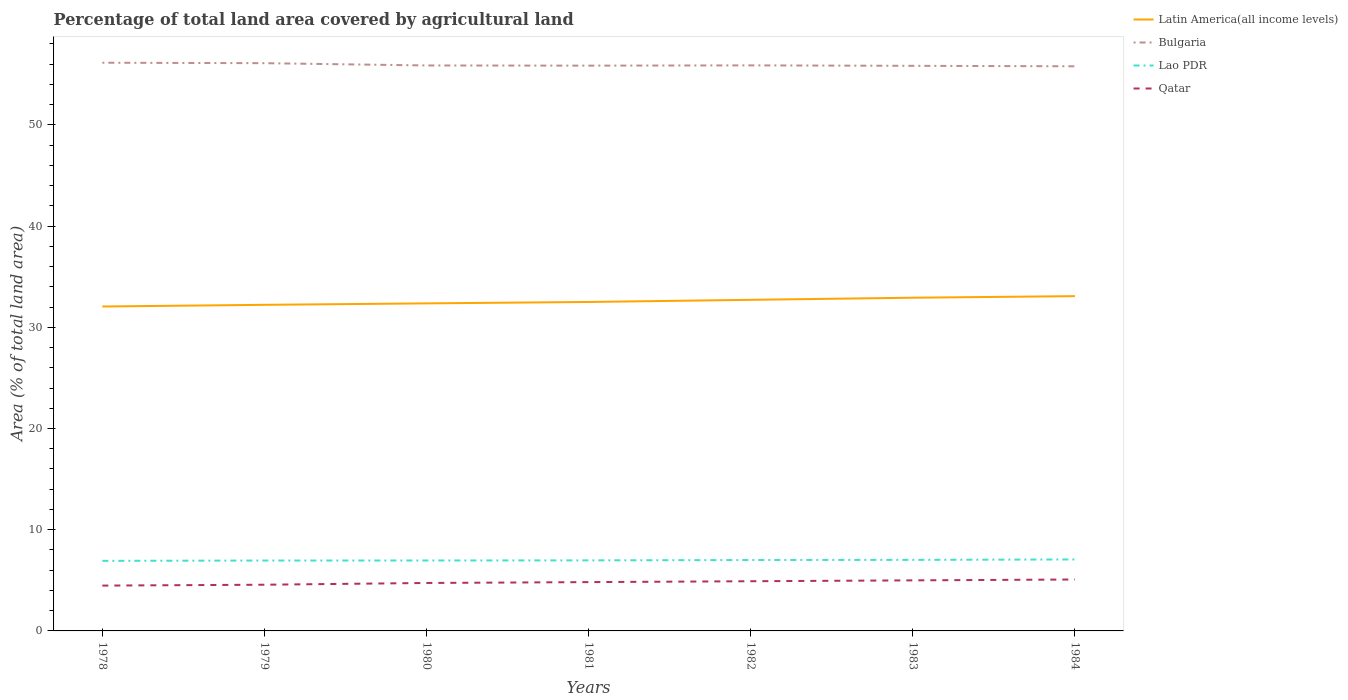Across all years, what is the maximum percentage of agricultural land in Bulgaria?
Provide a succinct answer. 55.79. What is the total percentage of agricultural land in Bulgaria in the graph?
Your response must be concise. 0.05. What is the difference between the highest and the second highest percentage of agricultural land in Lao PDR?
Give a very brief answer. 0.14. What is the difference between the highest and the lowest percentage of agricultural land in Qatar?
Provide a succinct answer. 4. Is the percentage of agricultural land in Qatar strictly greater than the percentage of agricultural land in Lao PDR over the years?
Your response must be concise. Yes. How many lines are there?
Ensure brevity in your answer.  4. What is the difference between two consecutive major ticks on the Y-axis?
Offer a terse response. 10. Are the values on the major ticks of Y-axis written in scientific E-notation?
Ensure brevity in your answer.  No. Does the graph contain any zero values?
Keep it short and to the point. No. Does the graph contain grids?
Give a very brief answer. No. How many legend labels are there?
Make the answer very short. 4. What is the title of the graph?
Provide a succinct answer. Percentage of total land area covered by agricultural land. What is the label or title of the Y-axis?
Offer a terse response. Area (% of total land area). What is the Area (% of total land area) of Latin America(all income levels) in 1978?
Provide a succinct answer. 32.05. What is the Area (% of total land area) in Bulgaria in 1978?
Ensure brevity in your answer.  56.14. What is the Area (% of total land area) of Lao PDR in 1978?
Your answer should be very brief. 6.92. What is the Area (% of total land area) of Qatar in 1978?
Ensure brevity in your answer.  4.48. What is the Area (% of total land area) of Latin America(all income levels) in 1979?
Your answer should be very brief. 32.22. What is the Area (% of total land area) in Bulgaria in 1979?
Your response must be concise. 56.1. What is the Area (% of total land area) of Lao PDR in 1979?
Offer a terse response. 6.95. What is the Area (% of total land area) of Qatar in 1979?
Provide a succinct answer. 4.57. What is the Area (% of total land area) in Latin America(all income levels) in 1980?
Your response must be concise. 32.36. What is the Area (% of total land area) of Bulgaria in 1980?
Offer a very short reply. 55.87. What is the Area (% of total land area) in Lao PDR in 1980?
Offer a very short reply. 6.96. What is the Area (% of total land area) of Qatar in 1980?
Offer a terse response. 4.74. What is the Area (% of total land area) of Latin America(all income levels) in 1981?
Provide a short and direct response. 32.5. What is the Area (% of total land area) of Bulgaria in 1981?
Give a very brief answer. 55.85. What is the Area (% of total land area) in Lao PDR in 1981?
Your answer should be very brief. 6.97. What is the Area (% of total land area) of Qatar in 1981?
Offer a terse response. 4.82. What is the Area (% of total land area) in Latin America(all income levels) in 1982?
Your answer should be compact. 32.71. What is the Area (% of total land area) of Bulgaria in 1982?
Your answer should be compact. 55.88. What is the Area (% of total land area) in Lao PDR in 1982?
Your answer should be compact. 7.01. What is the Area (% of total land area) in Qatar in 1982?
Ensure brevity in your answer.  4.91. What is the Area (% of total land area) in Latin America(all income levels) in 1983?
Offer a very short reply. 32.92. What is the Area (% of total land area) of Bulgaria in 1983?
Your answer should be compact. 55.83. What is the Area (% of total land area) of Lao PDR in 1983?
Your response must be concise. 7.02. What is the Area (% of total land area) in Qatar in 1983?
Keep it short and to the point. 5. What is the Area (% of total land area) of Latin America(all income levels) in 1984?
Offer a very short reply. 33.08. What is the Area (% of total land area) of Bulgaria in 1984?
Provide a succinct answer. 55.79. What is the Area (% of total land area) in Lao PDR in 1984?
Keep it short and to the point. 7.06. What is the Area (% of total land area) in Qatar in 1984?
Keep it short and to the point. 5.08. Across all years, what is the maximum Area (% of total land area) of Latin America(all income levels)?
Ensure brevity in your answer.  33.08. Across all years, what is the maximum Area (% of total land area) in Bulgaria?
Make the answer very short. 56.14. Across all years, what is the maximum Area (% of total land area) in Lao PDR?
Make the answer very short. 7.06. Across all years, what is the maximum Area (% of total land area) in Qatar?
Your answer should be compact. 5.08. Across all years, what is the minimum Area (% of total land area) of Latin America(all income levels)?
Keep it short and to the point. 32.05. Across all years, what is the minimum Area (% of total land area) in Bulgaria?
Your answer should be compact. 55.79. Across all years, what is the minimum Area (% of total land area) of Lao PDR?
Your answer should be very brief. 6.92. Across all years, what is the minimum Area (% of total land area) of Qatar?
Offer a very short reply. 4.48. What is the total Area (% of total land area) in Latin America(all income levels) in the graph?
Give a very brief answer. 227.86. What is the total Area (% of total land area) of Bulgaria in the graph?
Keep it short and to the point. 391.47. What is the total Area (% of total land area) of Lao PDR in the graph?
Make the answer very short. 48.9. What is the total Area (% of total land area) of Qatar in the graph?
Make the answer very short. 33.59. What is the difference between the Area (% of total land area) of Latin America(all income levels) in 1978 and that in 1979?
Offer a very short reply. -0.17. What is the difference between the Area (% of total land area) in Bulgaria in 1978 and that in 1979?
Ensure brevity in your answer.  0.05. What is the difference between the Area (% of total land area) of Lao PDR in 1978 and that in 1979?
Offer a very short reply. -0.03. What is the difference between the Area (% of total land area) in Qatar in 1978 and that in 1979?
Provide a succinct answer. -0.09. What is the difference between the Area (% of total land area) of Latin America(all income levels) in 1978 and that in 1980?
Ensure brevity in your answer.  -0.31. What is the difference between the Area (% of total land area) of Bulgaria in 1978 and that in 1980?
Keep it short and to the point. 0.27. What is the difference between the Area (% of total land area) in Lao PDR in 1978 and that in 1980?
Ensure brevity in your answer.  -0.03. What is the difference between the Area (% of total land area) of Qatar in 1978 and that in 1980?
Your answer should be compact. -0.26. What is the difference between the Area (% of total land area) of Latin America(all income levels) in 1978 and that in 1981?
Your answer should be very brief. -0.45. What is the difference between the Area (% of total land area) of Bulgaria in 1978 and that in 1981?
Provide a short and direct response. 0.29. What is the difference between the Area (% of total land area) of Lao PDR in 1978 and that in 1981?
Ensure brevity in your answer.  -0.05. What is the difference between the Area (% of total land area) of Qatar in 1978 and that in 1981?
Provide a short and direct response. -0.34. What is the difference between the Area (% of total land area) in Latin America(all income levels) in 1978 and that in 1982?
Keep it short and to the point. -0.66. What is the difference between the Area (% of total land area) of Bulgaria in 1978 and that in 1982?
Offer a terse response. 0.26. What is the difference between the Area (% of total land area) of Lao PDR in 1978 and that in 1982?
Give a very brief answer. -0.08. What is the difference between the Area (% of total land area) in Qatar in 1978 and that in 1982?
Your response must be concise. -0.43. What is the difference between the Area (% of total land area) in Latin America(all income levels) in 1978 and that in 1983?
Provide a short and direct response. -0.87. What is the difference between the Area (% of total land area) in Bulgaria in 1978 and that in 1983?
Keep it short and to the point. 0.31. What is the difference between the Area (% of total land area) in Lao PDR in 1978 and that in 1983?
Give a very brief answer. -0.1. What is the difference between the Area (% of total land area) of Qatar in 1978 and that in 1983?
Give a very brief answer. -0.52. What is the difference between the Area (% of total land area) in Latin America(all income levels) in 1978 and that in 1984?
Give a very brief answer. -1.02. What is the difference between the Area (% of total land area) in Bulgaria in 1978 and that in 1984?
Offer a terse response. 0.35. What is the difference between the Area (% of total land area) in Lao PDR in 1978 and that in 1984?
Offer a very short reply. -0.14. What is the difference between the Area (% of total land area) in Qatar in 1978 and that in 1984?
Ensure brevity in your answer.  -0.6. What is the difference between the Area (% of total land area) of Latin America(all income levels) in 1979 and that in 1980?
Your response must be concise. -0.14. What is the difference between the Area (% of total land area) in Bulgaria in 1979 and that in 1980?
Keep it short and to the point. 0.23. What is the difference between the Area (% of total land area) in Lao PDR in 1979 and that in 1980?
Offer a very short reply. -0. What is the difference between the Area (% of total land area) in Qatar in 1979 and that in 1980?
Your response must be concise. -0.17. What is the difference between the Area (% of total land area) in Latin America(all income levels) in 1979 and that in 1981?
Your answer should be very brief. -0.28. What is the difference between the Area (% of total land area) in Bulgaria in 1979 and that in 1981?
Give a very brief answer. 0.24. What is the difference between the Area (% of total land area) in Lao PDR in 1979 and that in 1981?
Make the answer very short. -0.02. What is the difference between the Area (% of total land area) of Qatar in 1979 and that in 1981?
Your response must be concise. -0.26. What is the difference between the Area (% of total land area) in Latin America(all income levels) in 1979 and that in 1982?
Ensure brevity in your answer.  -0.49. What is the difference between the Area (% of total land area) in Bulgaria in 1979 and that in 1982?
Ensure brevity in your answer.  0.22. What is the difference between the Area (% of total land area) of Lao PDR in 1979 and that in 1982?
Make the answer very short. -0.05. What is the difference between the Area (% of total land area) in Qatar in 1979 and that in 1982?
Keep it short and to the point. -0.34. What is the difference between the Area (% of total land area) in Latin America(all income levels) in 1979 and that in 1983?
Give a very brief answer. -0.7. What is the difference between the Area (% of total land area) of Bulgaria in 1979 and that in 1983?
Provide a succinct answer. 0.26. What is the difference between the Area (% of total land area) of Lao PDR in 1979 and that in 1983?
Give a very brief answer. -0.07. What is the difference between the Area (% of total land area) of Qatar in 1979 and that in 1983?
Provide a short and direct response. -0.43. What is the difference between the Area (% of total land area) in Latin America(all income levels) in 1979 and that in 1984?
Provide a succinct answer. -0.86. What is the difference between the Area (% of total land area) in Bulgaria in 1979 and that in 1984?
Make the answer very short. 0.31. What is the difference between the Area (% of total land area) in Lao PDR in 1979 and that in 1984?
Offer a terse response. -0.11. What is the difference between the Area (% of total land area) in Qatar in 1979 and that in 1984?
Make the answer very short. -0.52. What is the difference between the Area (% of total land area) in Latin America(all income levels) in 1980 and that in 1981?
Give a very brief answer. -0.14. What is the difference between the Area (% of total land area) in Bulgaria in 1980 and that in 1981?
Provide a succinct answer. 0.02. What is the difference between the Area (% of total land area) in Lao PDR in 1980 and that in 1981?
Provide a short and direct response. -0.01. What is the difference between the Area (% of total land area) in Qatar in 1980 and that in 1981?
Make the answer very short. -0.09. What is the difference between the Area (% of total land area) in Latin America(all income levels) in 1980 and that in 1982?
Ensure brevity in your answer.  -0.35. What is the difference between the Area (% of total land area) in Bulgaria in 1980 and that in 1982?
Keep it short and to the point. -0.01. What is the difference between the Area (% of total land area) in Lao PDR in 1980 and that in 1982?
Give a very brief answer. -0.05. What is the difference between the Area (% of total land area) in Qatar in 1980 and that in 1982?
Give a very brief answer. -0.17. What is the difference between the Area (% of total land area) of Latin America(all income levels) in 1980 and that in 1983?
Provide a short and direct response. -0.56. What is the difference between the Area (% of total land area) in Bulgaria in 1980 and that in 1983?
Give a very brief answer. 0.04. What is the difference between the Area (% of total land area) in Lao PDR in 1980 and that in 1983?
Make the answer very short. -0.06. What is the difference between the Area (% of total land area) of Qatar in 1980 and that in 1983?
Offer a terse response. -0.26. What is the difference between the Area (% of total land area) of Latin America(all income levels) in 1980 and that in 1984?
Keep it short and to the point. -0.71. What is the difference between the Area (% of total land area) in Bulgaria in 1980 and that in 1984?
Keep it short and to the point. 0.08. What is the difference between the Area (% of total land area) in Lao PDR in 1980 and that in 1984?
Offer a terse response. -0.1. What is the difference between the Area (% of total land area) in Qatar in 1980 and that in 1984?
Offer a terse response. -0.34. What is the difference between the Area (% of total land area) of Latin America(all income levels) in 1981 and that in 1982?
Ensure brevity in your answer.  -0.21. What is the difference between the Area (% of total land area) in Bulgaria in 1981 and that in 1982?
Your response must be concise. -0.03. What is the difference between the Area (% of total land area) in Lao PDR in 1981 and that in 1982?
Offer a terse response. -0.03. What is the difference between the Area (% of total land area) in Qatar in 1981 and that in 1982?
Offer a terse response. -0.09. What is the difference between the Area (% of total land area) in Latin America(all income levels) in 1981 and that in 1983?
Give a very brief answer. -0.42. What is the difference between the Area (% of total land area) of Bulgaria in 1981 and that in 1983?
Offer a very short reply. 0.02. What is the difference between the Area (% of total land area) of Lao PDR in 1981 and that in 1983?
Give a very brief answer. -0.05. What is the difference between the Area (% of total land area) in Qatar in 1981 and that in 1983?
Your response must be concise. -0.17. What is the difference between the Area (% of total land area) in Latin America(all income levels) in 1981 and that in 1984?
Keep it short and to the point. -0.58. What is the difference between the Area (% of total land area) of Bulgaria in 1981 and that in 1984?
Provide a succinct answer. 0.06. What is the difference between the Area (% of total land area) of Lao PDR in 1981 and that in 1984?
Your response must be concise. -0.09. What is the difference between the Area (% of total land area) of Qatar in 1981 and that in 1984?
Ensure brevity in your answer.  -0.26. What is the difference between the Area (% of total land area) of Latin America(all income levels) in 1982 and that in 1983?
Your response must be concise. -0.21. What is the difference between the Area (% of total land area) in Bulgaria in 1982 and that in 1983?
Provide a short and direct response. 0.05. What is the difference between the Area (% of total land area) of Lao PDR in 1982 and that in 1983?
Offer a very short reply. -0.01. What is the difference between the Area (% of total land area) of Qatar in 1982 and that in 1983?
Provide a short and direct response. -0.09. What is the difference between the Area (% of total land area) of Latin America(all income levels) in 1982 and that in 1984?
Provide a short and direct response. -0.36. What is the difference between the Area (% of total land area) of Bulgaria in 1982 and that in 1984?
Offer a very short reply. 0.09. What is the difference between the Area (% of total land area) in Lao PDR in 1982 and that in 1984?
Offer a very short reply. -0.06. What is the difference between the Area (% of total land area) of Qatar in 1982 and that in 1984?
Keep it short and to the point. -0.17. What is the difference between the Area (% of total land area) of Latin America(all income levels) in 1983 and that in 1984?
Your response must be concise. -0.16. What is the difference between the Area (% of total land area) of Bulgaria in 1983 and that in 1984?
Provide a short and direct response. 0.05. What is the difference between the Area (% of total land area) of Lao PDR in 1983 and that in 1984?
Make the answer very short. -0.04. What is the difference between the Area (% of total land area) of Qatar in 1983 and that in 1984?
Your response must be concise. -0.09. What is the difference between the Area (% of total land area) in Latin America(all income levels) in 1978 and the Area (% of total land area) in Bulgaria in 1979?
Your response must be concise. -24.04. What is the difference between the Area (% of total land area) of Latin America(all income levels) in 1978 and the Area (% of total land area) of Lao PDR in 1979?
Offer a terse response. 25.1. What is the difference between the Area (% of total land area) of Latin America(all income levels) in 1978 and the Area (% of total land area) of Qatar in 1979?
Your response must be concise. 27.49. What is the difference between the Area (% of total land area) in Bulgaria in 1978 and the Area (% of total land area) in Lao PDR in 1979?
Ensure brevity in your answer.  49.19. What is the difference between the Area (% of total land area) in Bulgaria in 1978 and the Area (% of total land area) in Qatar in 1979?
Provide a succinct answer. 51.58. What is the difference between the Area (% of total land area) of Lao PDR in 1978 and the Area (% of total land area) of Qatar in 1979?
Offer a very short reply. 2.36. What is the difference between the Area (% of total land area) of Latin America(all income levels) in 1978 and the Area (% of total land area) of Bulgaria in 1980?
Provide a succinct answer. -23.82. What is the difference between the Area (% of total land area) in Latin America(all income levels) in 1978 and the Area (% of total land area) in Lao PDR in 1980?
Offer a terse response. 25.1. What is the difference between the Area (% of total land area) of Latin America(all income levels) in 1978 and the Area (% of total land area) of Qatar in 1980?
Ensure brevity in your answer.  27.32. What is the difference between the Area (% of total land area) in Bulgaria in 1978 and the Area (% of total land area) in Lao PDR in 1980?
Offer a terse response. 49.18. What is the difference between the Area (% of total land area) in Bulgaria in 1978 and the Area (% of total land area) in Qatar in 1980?
Your response must be concise. 51.4. What is the difference between the Area (% of total land area) of Lao PDR in 1978 and the Area (% of total land area) of Qatar in 1980?
Make the answer very short. 2.19. What is the difference between the Area (% of total land area) of Latin America(all income levels) in 1978 and the Area (% of total land area) of Bulgaria in 1981?
Ensure brevity in your answer.  -23.8. What is the difference between the Area (% of total land area) of Latin America(all income levels) in 1978 and the Area (% of total land area) of Lao PDR in 1981?
Your response must be concise. 25.08. What is the difference between the Area (% of total land area) of Latin America(all income levels) in 1978 and the Area (% of total land area) of Qatar in 1981?
Provide a succinct answer. 27.23. What is the difference between the Area (% of total land area) in Bulgaria in 1978 and the Area (% of total land area) in Lao PDR in 1981?
Keep it short and to the point. 49.17. What is the difference between the Area (% of total land area) of Bulgaria in 1978 and the Area (% of total land area) of Qatar in 1981?
Offer a very short reply. 51.32. What is the difference between the Area (% of total land area) of Lao PDR in 1978 and the Area (% of total land area) of Qatar in 1981?
Offer a terse response. 2.1. What is the difference between the Area (% of total land area) in Latin America(all income levels) in 1978 and the Area (% of total land area) in Bulgaria in 1982?
Offer a very short reply. -23.83. What is the difference between the Area (% of total land area) of Latin America(all income levels) in 1978 and the Area (% of total land area) of Lao PDR in 1982?
Offer a terse response. 25.05. What is the difference between the Area (% of total land area) of Latin America(all income levels) in 1978 and the Area (% of total land area) of Qatar in 1982?
Provide a succinct answer. 27.15. What is the difference between the Area (% of total land area) of Bulgaria in 1978 and the Area (% of total land area) of Lao PDR in 1982?
Offer a very short reply. 49.14. What is the difference between the Area (% of total land area) in Bulgaria in 1978 and the Area (% of total land area) in Qatar in 1982?
Ensure brevity in your answer.  51.23. What is the difference between the Area (% of total land area) in Lao PDR in 1978 and the Area (% of total land area) in Qatar in 1982?
Your response must be concise. 2.01. What is the difference between the Area (% of total land area) in Latin America(all income levels) in 1978 and the Area (% of total land area) in Bulgaria in 1983?
Your answer should be compact. -23.78. What is the difference between the Area (% of total land area) of Latin America(all income levels) in 1978 and the Area (% of total land area) of Lao PDR in 1983?
Give a very brief answer. 25.04. What is the difference between the Area (% of total land area) of Latin America(all income levels) in 1978 and the Area (% of total land area) of Qatar in 1983?
Your response must be concise. 27.06. What is the difference between the Area (% of total land area) in Bulgaria in 1978 and the Area (% of total land area) in Lao PDR in 1983?
Offer a terse response. 49.12. What is the difference between the Area (% of total land area) in Bulgaria in 1978 and the Area (% of total land area) in Qatar in 1983?
Provide a succinct answer. 51.15. What is the difference between the Area (% of total land area) of Lao PDR in 1978 and the Area (% of total land area) of Qatar in 1983?
Provide a succinct answer. 1.93. What is the difference between the Area (% of total land area) in Latin America(all income levels) in 1978 and the Area (% of total land area) in Bulgaria in 1984?
Your answer should be compact. -23.73. What is the difference between the Area (% of total land area) in Latin America(all income levels) in 1978 and the Area (% of total land area) in Lao PDR in 1984?
Offer a terse response. 24.99. What is the difference between the Area (% of total land area) in Latin America(all income levels) in 1978 and the Area (% of total land area) in Qatar in 1984?
Provide a succinct answer. 26.97. What is the difference between the Area (% of total land area) in Bulgaria in 1978 and the Area (% of total land area) in Lao PDR in 1984?
Provide a short and direct response. 49.08. What is the difference between the Area (% of total land area) in Bulgaria in 1978 and the Area (% of total land area) in Qatar in 1984?
Your response must be concise. 51.06. What is the difference between the Area (% of total land area) of Lao PDR in 1978 and the Area (% of total land area) of Qatar in 1984?
Your answer should be compact. 1.84. What is the difference between the Area (% of total land area) in Latin America(all income levels) in 1979 and the Area (% of total land area) in Bulgaria in 1980?
Offer a terse response. -23.65. What is the difference between the Area (% of total land area) in Latin America(all income levels) in 1979 and the Area (% of total land area) in Lao PDR in 1980?
Provide a short and direct response. 25.26. What is the difference between the Area (% of total land area) of Latin America(all income levels) in 1979 and the Area (% of total land area) of Qatar in 1980?
Provide a succinct answer. 27.48. What is the difference between the Area (% of total land area) of Bulgaria in 1979 and the Area (% of total land area) of Lao PDR in 1980?
Your answer should be very brief. 49.14. What is the difference between the Area (% of total land area) of Bulgaria in 1979 and the Area (% of total land area) of Qatar in 1980?
Provide a succinct answer. 51.36. What is the difference between the Area (% of total land area) of Lao PDR in 1979 and the Area (% of total land area) of Qatar in 1980?
Your answer should be compact. 2.22. What is the difference between the Area (% of total land area) in Latin America(all income levels) in 1979 and the Area (% of total land area) in Bulgaria in 1981?
Your answer should be very brief. -23.63. What is the difference between the Area (% of total land area) of Latin America(all income levels) in 1979 and the Area (% of total land area) of Lao PDR in 1981?
Offer a terse response. 25.25. What is the difference between the Area (% of total land area) of Latin America(all income levels) in 1979 and the Area (% of total land area) of Qatar in 1981?
Make the answer very short. 27.4. What is the difference between the Area (% of total land area) of Bulgaria in 1979 and the Area (% of total land area) of Lao PDR in 1981?
Offer a terse response. 49.13. What is the difference between the Area (% of total land area) in Bulgaria in 1979 and the Area (% of total land area) in Qatar in 1981?
Your answer should be very brief. 51.27. What is the difference between the Area (% of total land area) in Lao PDR in 1979 and the Area (% of total land area) in Qatar in 1981?
Provide a short and direct response. 2.13. What is the difference between the Area (% of total land area) of Latin America(all income levels) in 1979 and the Area (% of total land area) of Bulgaria in 1982?
Make the answer very short. -23.66. What is the difference between the Area (% of total land area) of Latin America(all income levels) in 1979 and the Area (% of total land area) of Lao PDR in 1982?
Ensure brevity in your answer.  25.21. What is the difference between the Area (% of total land area) of Latin America(all income levels) in 1979 and the Area (% of total land area) of Qatar in 1982?
Offer a very short reply. 27.31. What is the difference between the Area (% of total land area) of Bulgaria in 1979 and the Area (% of total land area) of Lao PDR in 1982?
Offer a terse response. 49.09. What is the difference between the Area (% of total land area) of Bulgaria in 1979 and the Area (% of total land area) of Qatar in 1982?
Make the answer very short. 51.19. What is the difference between the Area (% of total land area) of Lao PDR in 1979 and the Area (% of total land area) of Qatar in 1982?
Give a very brief answer. 2.04. What is the difference between the Area (% of total land area) of Latin America(all income levels) in 1979 and the Area (% of total land area) of Bulgaria in 1983?
Offer a very short reply. -23.61. What is the difference between the Area (% of total land area) of Latin America(all income levels) in 1979 and the Area (% of total land area) of Lao PDR in 1983?
Provide a short and direct response. 25.2. What is the difference between the Area (% of total land area) of Latin America(all income levels) in 1979 and the Area (% of total land area) of Qatar in 1983?
Your response must be concise. 27.22. What is the difference between the Area (% of total land area) of Bulgaria in 1979 and the Area (% of total land area) of Lao PDR in 1983?
Keep it short and to the point. 49.08. What is the difference between the Area (% of total land area) in Bulgaria in 1979 and the Area (% of total land area) in Qatar in 1983?
Your response must be concise. 51.1. What is the difference between the Area (% of total land area) of Lao PDR in 1979 and the Area (% of total land area) of Qatar in 1983?
Keep it short and to the point. 1.96. What is the difference between the Area (% of total land area) of Latin America(all income levels) in 1979 and the Area (% of total land area) of Bulgaria in 1984?
Give a very brief answer. -23.57. What is the difference between the Area (% of total land area) of Latin America(all income levels) in 1979 and the Area (% of total land area) of Lao PDR in 1984?
Your answer should be compact. 25.16. What is the difference between the Area (% of total land area) in Latin America(all income levels) in 1979 and the Area (% of total land area) in Qatar in 1984?
Ensure brevity in your answer.  27.14. What is the difference between the Area (% of total land area) in Bulgaria in 1979 and the Area (% of total land area) in Lao PDR in 1984?
Give a very brief answer. 49.03. What is the difference between the Area (% of total land area) in Bulgaria in 1979 and the Area (% of total land area) in Qatar in 1984?
Offer a very short reply. 51.02. What is the difference between the Area (% of total land area) of Lao PDR in 1979 and the Area (% of total land area) of Qatar in 1984?
Your response must be concise. 1.87. What is the difference between the Area (% of total land area) in Latin America(all income levels) in 1980 and the Area (% of total land area) in Bulgaria in 1981?
Make the answer very short. -23.49. What is the difference between the Area (% of total land area) of Latin America(all income levels) in 1980 and the Area (% of total land area) of Lao PDR in 1981?
Provide a succinct answer. 25.39. What is the difference between the Area (% of total land area) of Latin America(all income levels) in 1980 and the Area (% of total land area) of Qatar in 1981?
Your answer should be very brief. 27.54. What is the difference between the Area (% of total land area) of Bulgaria in 1980 and the Area (% of total land area) of Lao PDR in 1981?
Your answer should be very brief. 48.9. What is the difference between the Area (% of total land area) in Bulgaria in 1980 and the Area (% of total land area) in Qatar in 1981?
Your answer should be compact. 51.05. What is the difference between the Area (% of total land area) of Lao PDR in 1980 and the Area (% of total land area) of Qatar in 1981?
Ensure brevity in your answer.  2.13. What is the difference between the Area (% of total land area) in Latin America(all income levels) in 1980 and the Area (% of total land area) in Bulgaria in 1982?
Ensure brevity in your answer.  -23.52. What is the difference between the Area (% of total land area) in Latin America(all income levels) in 1980 and the Area (% of total land area) in Lao PDR in 1982?
Keep it short and to the point. 25.36. What is the difference between the Area (% of total land area) in Latin America(all income levels) in 1980 and the Area (% of total land area) in Qatar in 1982?
Provide a succinct answer. 27.45. What is the difference between the Area (% of total land area) in Bulgaria in 1980 and the Area (% of total land area) in Lao PDR in 1982?
Keep it short and to the point. 48.86. What is the difference between the Area (% of total land area) in Bulgaria in 1980 and the Area (% of total land area) in Qatar in 1982?
Your response must be concise. 50.96. What is the difference between the Area (% of total land area) of Lao PDR in 1980 and the Area (% of total land area) of Qatar in 1982?
Your answer should be very brief. 2.05. What is the difference between the Area (% of total land area) in Latin America(all income levels) in 1980 and the Area (% of total land area) in Bulgaria in 1983?
Ensure brevity in your answer.  -23.47. What is the difference between the Area (% of total land area) in Latin America(all income levels) in 1980 and the Area (% of total land area) in Lao PDR in 1983?
Offer a very short reply. 25.34. What is the difference between the Area (% of total land area) in Latin America(all income levels) in 1980 and the Area (% of total land area) in Qatar in 1983?
Keep it short and to the point. 27.37. What is the difference between the Area (% of total land area) of Bulgaria in 1980 and the Area (% of total land area) of Lao PDR in 1983?
Offer a very short reply. 48.85. What is the difference between the Area (% of total land area) of Bulgaria in 1980 and the Area (% of total land area) of Qatar in 1983?
Give a very brief answer. 50.88. What is the difference between the Area (% of total land area) in Lao PDR in 1980 and the Area (% of total land area) in Qatar in 1983?
Offer a very short reply. 1.96. What is the difference between the Area (% of total land area) of Latin America(all income levels) in 1980 and the Area (% of total land area) of Bulgaria in 1984?
Your answer should be very brief. -23.43. What is the difference between the Area (% of total land area) in Latin America(all income levels) in 1980 and the Area (% of total land area) in Lao PDR in 1984?
Give a very brief answer. 25.3. What is the difference between the Area (% of total land area) in Latin America(all income levels) in 1980 and the Area (% of total land area) in Qatar in 1984?
Offer a terse response. 27.28. What is the difference between the Area (% of total land area) in Bulgaria in 1980 and the Area (% of total land area) in Lao PDR in 1984?
Provide a short and direct response. 48.81. What is the difference between the Area (% of total land area) in Bulgaria in 1980 and the Area (% of total land area) in Qatar in 1984?
Make the answer very short. 50.79. What is the difference between the Area (% of total land area) in Lao PDR in 1980 and the Area (% of total land area) in Qatar in 1984?
Your answer should be very brief. 1.88. What is the difference between the Area (% of total land area) in Latin America(all income levels) in 1981 and the Area (% of total land area) in Bulgaria in 1982?
Offer a terse response. -23.38. What is the difference between the Area (% of total land area) in Latin America(all income levels) in 1981 and the Area (% of total land area) in Lao PDR in 1982?
Your answer should be very brief. 25.5. What is the difference between the Area (% of total land area) of Latin America(all income levels) in 1981 and the Area (% of total land area) of Qatar in 1982?
Give a very brief answer. 27.59. What is the difference between the Area (% of total land area) in Bulgaria in 1981 and the Area (% of total land area) in Lao PDR in 1982?
Give a very brief answer. 48.85. What is the difference between the Area (% of total land area) in Bulgaria in 1981 and the Area (% of total land area) in Qatar in 1982?
Provide a short and direct response. 50.94. What is the difference between the Area (% of total land area) in Lao PDR in 1981 and the Area (% of total land area) in Qatar in 1982?
Keep it short and to the point. 2.06. What is the difference between the Area (% of total land area) of Latin America(all income levels) in 1981 and the Area (% of total land area) of Bulgaria in 1983?
Give a very brief answer. -23.33. What is the difference between the Area (% of total land area) of Latin America(all income levels) in 1981 and the Area (% of total land area) of Lao PDR in 1983?
Keep it short and to the point. 25.48. What is the difference between the Area (% of total land area) of Latin America(all income levels) in 1981 and the Area (% of total land area) of Qatar in 1983?
Keep it short and to the point. 27.51. What is the difference between the Area (% of total land area) in Bulgaria in 1981 and the Area (% of total land area) in Lao PDR in 1983?
Offer a terse response. 48.83. What is the difference between the Area (% of total land area) in Bulgaria in 1981 and the Area (% of total land area) in Qatar in 1983?
Provide a short and direct response. 50.86. What is the difference between the Area (% of total land area) of Lao PDR in 1981 and the Area (% of total land area) of Qatar in 1983?
Ensure brevity in your answer.  1.98. What is the difference between the Area (% of total land area) of Latin America(all income levels) in 1981 and the Area (% of total land area) of Bulgaria in 1984?
Give a very brief answer. -23.29. What is the difference between the Area (% of total land area) in Latin America(all income levels) in 1981 and the Area (% of total land area) in Lao PDR in 1984?
Give a very brief answer. 25.44. What is the difference between the Area (% of total land area) of Latin America(all income levels) in 1981 and the Area (% of total land area) of Qatar in 1984?
Offer a terse response. 27.42. What is the difference between the Area (% of total land area) in Bulgaria in 1981 and the Area (% of total land area) in Lao PDR in 1984?
Your answer should be very brief. 48.79. What is the difference between the Area (% of total land area) of Bulgaria in 1981 and the Area (% of total land area) of Qatar in 1984?
Provide a succinct answer. 50.77. What is the difference between the Area (% of total land area) of Lao PDR in 1981 and the Area (% of total land area) of Qatar in 1984?
Provide a succinct answer. 1.89. What is the difference between the Area (% of total land area) of Latin America(all income levels) in 1982 and the Area (% of total land area) of Bulgaria in 1983?
Your response must be concise. -23.12. What is the difference between the Area (% of total land area) of Latin America(all income levels) in 1982 and the Area (% of total land area) of Lao PDR in 1983?
Offer a very short reply. 25.69. What is the difference between the Area (% of total land area) of Latin America(all income levels) in 1982 and the Area (% of total land area) of Qatar in 1983?
Provide a short and direct response. 27.72. What is the difference between the Area (% of total land area) of Bulgaria in 1982 and the Area (% of total land area) of Lao PDR in 1983?
Provide a short and direct response. 48.86. What is the difference between the Area (% of total land area) in Bulgaria in 1982 and the Area (% of total land area) in Qatar in 1983?
Offer a very short reply. 50.88. What is the difference between the Area (% of total land area) in Lao PDR in 1982 and the Area (% of total land area) in Qatar in 1983?
Offer a very short reply. 2.01. What is the difference between the Area (% of total land area) in Latin America(all income levels) in 1982 and the Area (% of total land area) in Bulgaria in 1984?
Keep it short and to the point. -23.08. What is the difference between the Area (% of total land area) in Latin America(all income levels) in 1982 and the Area (% of total land area) in Lao PDR in 1984?
Keep it short and to the point. 25.65. What is the difference between the Area (% of total land area) of Latin America(all income levels) in 1982 and the Area (% of total land area) of Qatar in 1984?
Your answer should be compact. 27.63. What is the difference between the Area (% of total land area) in Bulgaria in 1982 and the Area (% of total land area) in Lao PDR in 1984?
Offer a terse response. 48.82. What is the difference between the Area (% of total land area) in Bulgaria in 1982 and the Area (% of total land area) in Qatar in 1984?
Give a very brief answer. 50.8. What is the difference between the Area (% of total land area) in Lao PDR in 1982 and the Area (% of total land area) in Qatar in 1984?
Offer a terse response. 1.92. What is the difference between the Area (% of total land area) of Latin America(all income levels) in 1983 and the Area (% of total land area) of Bulgaria in 1984?
Provide a short and direct response. -22.87. What is the difference between the Area (% of total land area) of Latin America(all income levels) in 1983 and the Area (% of total land area) of Lao PDR in 1984?
Your answer should be very brief. 25.86. What is the difference between the Area (% of total land area) of Latin America(all income levels) in 1983 and the Area (% of total land area) of Qatar in 1984?
Offer a very short reply. 27.84. What is the difference between the Area (% of total land area) of Bulgaria in 1983 and the Area (% of total land area) of Lao PDR in 1984?
Give a very brief answer. 48.77. What is the difference between the Area (% of total land area) of Bulgaria in 1983 and the Area (% of total land area) of Qatar in 1984?
Your response must be concise. 50.75. What is the difference between the Area (% of total land area) in Lao PDR in 1983 and the Area (% of total land area) in Qatar in 1984?
Give a very brief answer. 1.94. What is the average Area (% of total land area) of Latin America(all income levels) per year?
Offer a terse response. 32.55. What is the average Area (% of total land area) in Bulgaria per year?
Your answer should be compact. 55.92. What is the average Area (% of total land area) in Lao PDR per year?
Offer a terse response. 6.99. What is the average Area (% of total land area) in Qatar per year?
Your answer should be very brief. 4.8. In the year 1978, what is the difference between the Area (% of total land area) in Latin America(all income levels) and Area (% of total land area) in Bulgaria?
Keep it short and to the point. -24.09. In the year 1978, what is the difference between the Area (% of total land area) in Latin America(all income levels) and Area (% of total land area) in Lao PDR?
Keep it short and to the point. 25.13. In the year 1978, what is the difference between the Area (% of total land area) in Latin America(all income levels) and Area (% of total land area) in Qatar?
Offer a very short reply. 27.58. In the year 1978, what is the difference between the Area (% of total land area) in Bulgaria and Area (% of total land area) in Lao PDR?
Offer a terse response. 49.22. In the year 1978, what is the difference between the Area (% of total land area) in Bulgaria and Area (% of total land area) in Qatar?
Provide a short and direct response. 51.66. In the year 1978, what is the difference between the Area (% of total land area) in Lao PDR and Area (% of total land area) in Qatar?
Give a very brief answer. 2.44. In the year 1979, what is the difference between the Area (% of total land area) in Latin America(all income levels) and Area (% of total land area) in Bulgaria?
Your response must be concise. -23.88. In the year 1979, what is the difference between the Area (% of total land area) in Latin America(all income levels) and Area (% of total land area) in Lao PDR?
Keep it short and to the point. 25.27. In the year 1979, what is the difference between the Area (% of total land area) of Latin America(all income levels) and Area (% of total land area) of Qatar?
Keep it short and to the point. 27.65. In the year 1979, what is the difference between the Area (% of total land area) of Bulgaria and Area (% of total land area) of Lao PDR?
Your answer should be compact. 49.14. In the year 1979, what is the difference between the Area (% of total land area) in Bulgaria and Area (% of total land area) in Qatar?
Your answer should be very brief. 51.53. In the year 1979, what is the difference between the Area (% of total land area) in Lao PDR and Area (% of total land area) in Qatar?
Your response must be concise. 2.39. In the year 1980, what is the difference between the Area (% of total land area) of Latin America(all income levels) and Area (% of total land area) of Bulgaria?
Give a very brief answer. -23.51. In the year 1980, what is the difference between the Area (% of total land area) of Latin America(all income levels) and Area (% of total land area) of Lao PDR?
Make the answer very short. 25.41. In the year 1980, what is the difference between the Area (% of total land area) of Latin America(all income levels) and Area (% of total land area) of Qatar?
Provide a short and direct response. 27.63. In the year 1980, what is the difference between the Area (% of total land area) in Bulgaria and Area (% of total land area) in Lao PDR?
Provide a short and direct response. 48.91. In the year 1980, what is the difference between the Area (% of total land area) in Bulgaria and Area (% of total land area) in Qatar?
Provide a succinct answer. 51.13. In the year 1980, what is the difference between the Area (% of total land area) of Lao PDR and Area (% of total land area) of Qatar?
Your response must be concise. 2.22. In the year 1981, what is the difference between the Area (% of total land area) in Latin America(all income levels) and Area (% of total land area) in Bulgaria?
Ensure brevity in your answer.  -23.35. In the year 1981, what is the difference between the Area (% of total land area) in Latin America(all income levels) and Area (% of total land area) in Lao PDR?
Provide a succinct answer. 25.53. In the year 1981, what is the difference between the Area (% of total land area) in Latin America(all income levels) and Area (% of total land area) in Qatar?
Your answer should be compact. 27.68. In the year 1981, what is the difference between the Area (% of total land area) of Bulgaria and Area (% of total land area) of Lao PDR?
Your answer should be compact. 48.88. In the year 1981, what is the difference between the Area (% of total land area) of Bulgaria and Area (% of total land area) of Qatar?
Give a very brief answer. 51.03. In the year 1981, what is the difference between the Area (% of total land area) in Lao PDR and Area (% of total land area) in Qatar?
Offer a very short reply. 2.15. In the year 1982, what is the difference between the Area (% of total land area) of Latin America(all income levels) and Area (% of total land area) of Bulgaria?
Provide a short and direct response. -23.17. In the year 1982, what is the difference between the Area (% of total land area) in Latin America(all income levels) and Area (% of total land area) in Lao PDR?
Ensure brevity in your answer.  25.71. In the year 1982, what is the difference between the Area (% of total land area) in Latin America(all income levels) and Area (% of total land area) in Qatar?
Your response must be concise. 27.8. In the year 1982, what is the difference between the Area (% of total land area) of Bulgaria and Area (% of total land area) of Lao PDR?
Offer a very short reply. 48.87. In the year 1982, what is the difference between the Area (% of total land area) in Bulgaria and Area (% of total land area) in Qatar?
Provide a succinct answer. 50.97. In the year 1982, what is the difference between the Area (% of total land area) of Lao PDR and Area (% of total land area) of Qatar?
Provide a short and direct response. 2.1. In the year 1983, what is the difference between the Area (% of total land area) of Latin America(all income levels) and Area (% of total land area) of Bulgaria?
Provide a short and direct response. -22.91. In the year 1983, what is the difference between the Area (% of total land area) in Latin America(all income levels) and Area (% of total land area) in Lao PDR?
Give a very brief answer. 25.9. In the year 1983, what is the difference between the Area (% of total land area) in Latin America(all income levels) and Area (% of total land area) in Qatar?
Your response must be concise. 27.93. In the year 1983, what is the difference between the Area (% of total land area) in Bulgaria and Area (% of total land area) in Lao PDR?
Your answer should be compact. 48.82. In the year 1983, what is the difference between the Area (% of total land area) of Bulgaria and Area (% of total land area) of Qatar?
Provide a short and direct response. 50.84. In the year 1983, what is the difference between the Area (% of total land area) in Lao PDR and Area (% of total land area) in Qatar?
Provide a succinct answer. 2.02. In the year 1984, what is the difference between the Area (% of total land area) of Latin America(all income levels) and Area (% of total land area) of Bulgaria?
Make the answer very short. -22.71. In the year 1984, what is the difference between the Area (% of total land area) in Latin America(all income levels) and Area (% of total land area) in Lao PDR?
Your response must be concise. 26.02. In the year 1984, what is the difference between the Area (% of total land area) of Latin America(all income levels) and Area (% of total land area) of Qatar?
Your response must be concise. 28. In the year 1984, what is the difference between the Area (% of total land area) of Bulgaria and Area (% of total land area) of Lao PDR?
Provide a short and direct response. 48.73. In the year 1984, what is the difference between the Area (% of total land area) in Bulgaria and Area (% of total land area) in Qatar?
Provide a short and direct response. 50.71. In the year 1984, what is the difference between the Area (% of total land area) in Lao PDR and Area (% of total land area) in Qatar?
Give a very brief answer. 1.98. What is the ratio of the Area (% of total land area) in Latin America(all income levels) in 1978 to that in 1979?
Offer a very short reply. 0.99. What is the ratio of the Area (% of total land area) in Bulgaria in 1978 to that in 1979?
Make the answer very short. 1. What is the ratio of the Area (% of total land area) in Qatar in 1978 to that in 1979?
Give a very brief answer. 0.98. What is the ratio of the Area (% of total land area) in Latin America(all income levels) in 1978 to that in 1980?
Keep it short and to the point. 0.99. What is the ratio of the Area (% of total land area) in Lao PDR in 1978 to that in 1980?
Make the answer very short. 0.99. What is the ratio of the Area (% of total land area) in Qatar in 1978 to that in 1980?
Offer a very short reply. 0.95. What is the ratio of the Area (% of total land area) in Latin America(all income levels) in 1978 to that in 1981?
Your response must be concise. 0.99. What is the ratio of the Area (% of total land area) in Qatar in 1978 to that in 1981?
Offer a terse response. 0.93. What is the ratio of the Area (% of total land area) in Latin America(all income levels) in 1978 to that in 1982?
Give a very brief answer. 0.98. What is the ratio of the Area (% of total land area) in Bulgaria in 1978 to that in 1982?
Make the answer very short. 1. What is the ratio of the Area (% of total land area) in Lao PDR in 1978 to that in 1982?
Your answer should be very brief. 0.99. What is the ratio of the Area (% of total land area) of Qatar in 1978 to that in 1982?
Your answer should be very brief. 0.91. What is the ratio of the Area (% of total land area) of Latin America(all income levels) in 1978 to that in 1983?
Provide a short and direct response. 0.97. What is the ratio of the Area (% of total land area) in Lao PDR in 1978 to that in 1983?
Give a very brief answer. 0.99. What is the ratio of the Area (% of total land area) of Qatar in 1978 to that in 1983?
Offer a terse response. 0.9. What is the ratio of the Area (% of total land area) in Lao PDR in 1978 to that in 1984?
Give a very brief answer. 0.98. What is the ratio of the Area (% of total land area) in Qatar in 1978 to that in 1984?
Provide a succinct answer. 0.88. What is the ratio of the Area (% of total land area) in Bulgaria in 1979 to that in 1980?
Your answer should be compact. 1. What is the ratio of the Area (% of total land area) of Qatar in 1979 to that in 1980?
Your answer should be compact. 0.96. What is the ratio of the Area (% of total land area) in Latin America(all income levels) in 1979 to that in 1981?
Your answer should be very brief. 0.99. What is the ratio of the Area (% of total land area) in Lao PDR in 1979 to that in 1981?
Keep it short and to the point. 1. What is the ratio of the Area (% of total land area) in Qatar in 1979 to that in 1981?
Make the answer very short. 0.95. What is the ratio of the Area (% of total land area) of Latin America(all income levels) in 1979 to that in 1982?
Give a very brief answer. 0.98. What is the ratio of the Area (% of total land area) of Bulgaria in 1979 to that in 1982?
Your answer should be very brief. 1. What is the ratio of the Area (% of total land area) in Qatar in 1979 to that in 1982?
Offer a very short reply. 0.93. What is the ratio of the Area (% of total land area) of Latin America(all income levels) in 1979 to that in 1983?
Offer a terse response. 0.98. What is the ratio of the Area (% of total land area) in Lao PDR in 1979 to that in 1983?
Keep it short and to the point. 0.99. What is the ratio of the Area (% of total land area) of Qatar in 1979 to that in 1983?
Provide a short and direct response. 0.91. What is the ratio of the Area (% of total land area) of Bulgaria in 1979 to that in 1984?
Ensure brevity in your answer.  1.01. What is the ratio of the Area (% of total land area) in Lao PDR in 1979 to that in 1984?
Offer a very short reply. 0.98. What is the ratio of the Area (% of total land area) in Qatar in 1979 to that in 1984?
Your answer should be compact. 0.9. What is the ratio of the Area (% of total land area) in Latin America(all income levels) in 1980 to that in 1981?
Keep it short and to the point. 1. What is the ratio of the Area (% of total land area) of Qatar in 1980 to that in 1981?
Your answer should be compact. 0.98. What is the ratio of the Area (% of total land area) of Latin America(all income levels) in 1980 to that in 1982?
Your answer should be very brief. 0.99. What is the ratio of the Area (% of total land area) of Bulgaria in 1980 to that in 1982?
Provide a succinct answer. 1. What is the ratio of the Area (% of total land area) of Qatar in 1980 to that in 1982?
Make the answer very short. 0.96. What is the ratio of the Area (% of total land area) of Latin America(all income levels) in 1980 to that in 1983?
Offer a terse response. 0.98. What is the ratio of the Area (% of total land area) of Lao PDR in 1980 to that in 1983?
Give a very brief answer. 0.99. What is the ratio of the Area (% of total land area) in Qatar in 1980 to that in 1983?
Make the answer very short. 0.95. What is the ratio of the Area (% of total land area) in Latin America(all income levels) in 1980 to that in 1984?
Offer a very short reply. 0.98. What is the ratio of the Area (% of total land area) in Qatar in 1980 to that in 1984?
Your answer should be compact. 0.93. What is the ratio of the Area (% of total land area) of Bulgaria in 1981 to that in 1982?
Offer a very short reply. 1. What is the ratio of the Area (% of total land area) of Qatar in 1981 to that in 1982?
Your response must be concise. 0.98. What is the ratio of the Area (% of total land area) of Latin America(all income levels) in 1981 to that in 1983?
Your answer should be compact. 0.99. What is the ratio of the Area (% of total land area) of Bulgaria in 1981 to that in 1983?
Your answer should be compact. 1. What is the ratio of the Area (% of total land area) in Qatar in 1981 to that in 1983?
Provide a succinct answer. 0.97. What is the ratio of the Area (% of total land area) in Latin America(all income levels) in 1981 to that in 1984?
Provide a succinct answer. 0.98. What is the ratio of the Area (% of total land area) of Lao PDR in 1981 to that in 1984?
Provide a succinct answer. 0.99. What is the ratio of the Area (% of total land area) of Qatar in 1981 to that in 1984?
Your answer should be very brief. 0.95. What is the ratio of the Area (% of total land area) of Lao PDR in 1982 to that in 1983?
Provide a short and direct response. 1. What is the ratio of the Area (% of total land area) of Qatar in 1982 to that in 1983?
Make the answer very short. 0.98. What is the ratio of the Area (% of total land area) in Latin America(all income levels) in 1982 to that in 1984?
Your answer should be compact. 0.99. What is the ratio of the Area (% of total land area) of Qatar in 1982 to that in 1984?
Provide a short and direct response. 0.97. What is the ratio of the Area (% of total land area) in Latin America(all income levels) in 1983 to that in 1984?
Give a very brief answer. 1. What is the ratio of the Area (% of total land area) of Bulgaria in 1983 to that in 1984?
Provide a succinct answer. 1. What is the ratio of the Area (% of total land area) in Qatar in 1983 to that in 1984?
Provide a succinct answer. 0.98. What is the difference between the highest and the second highest Area (% of total land area) in Latin America(all income levels)?
Provide a succinct answer. 0.16. What is the difference between the highest and the second highest Area (% of total land area) of Bulgaria?
Keep it short and to the point. 0.05. What is the difference between the highest and the second highest Area (% of total land area) in Lao PDR?
Your answer should be very brief. 0.04. What is the difference between the highest and the second highest Area (% of total land area) of Qatar?
Offer a very short reply. 0.09. What is the difference between the highest and the lowest Area (% of total land area) of Latin America(all income levels)?
Give a very brief answer. 1.02. What is the difference between the highest and the lowest Area (% of total land area) in Bulgaria?
Keep it short and to the point. 0.35. What is the difference between the highest and the lowest Area (% of total land area) in Lao PDR?
Offer a terse response. 0.14. What is the difference between the highest and the lowest Area (% of total land area) in Qatar?
Make the answer very short. 0.6. 